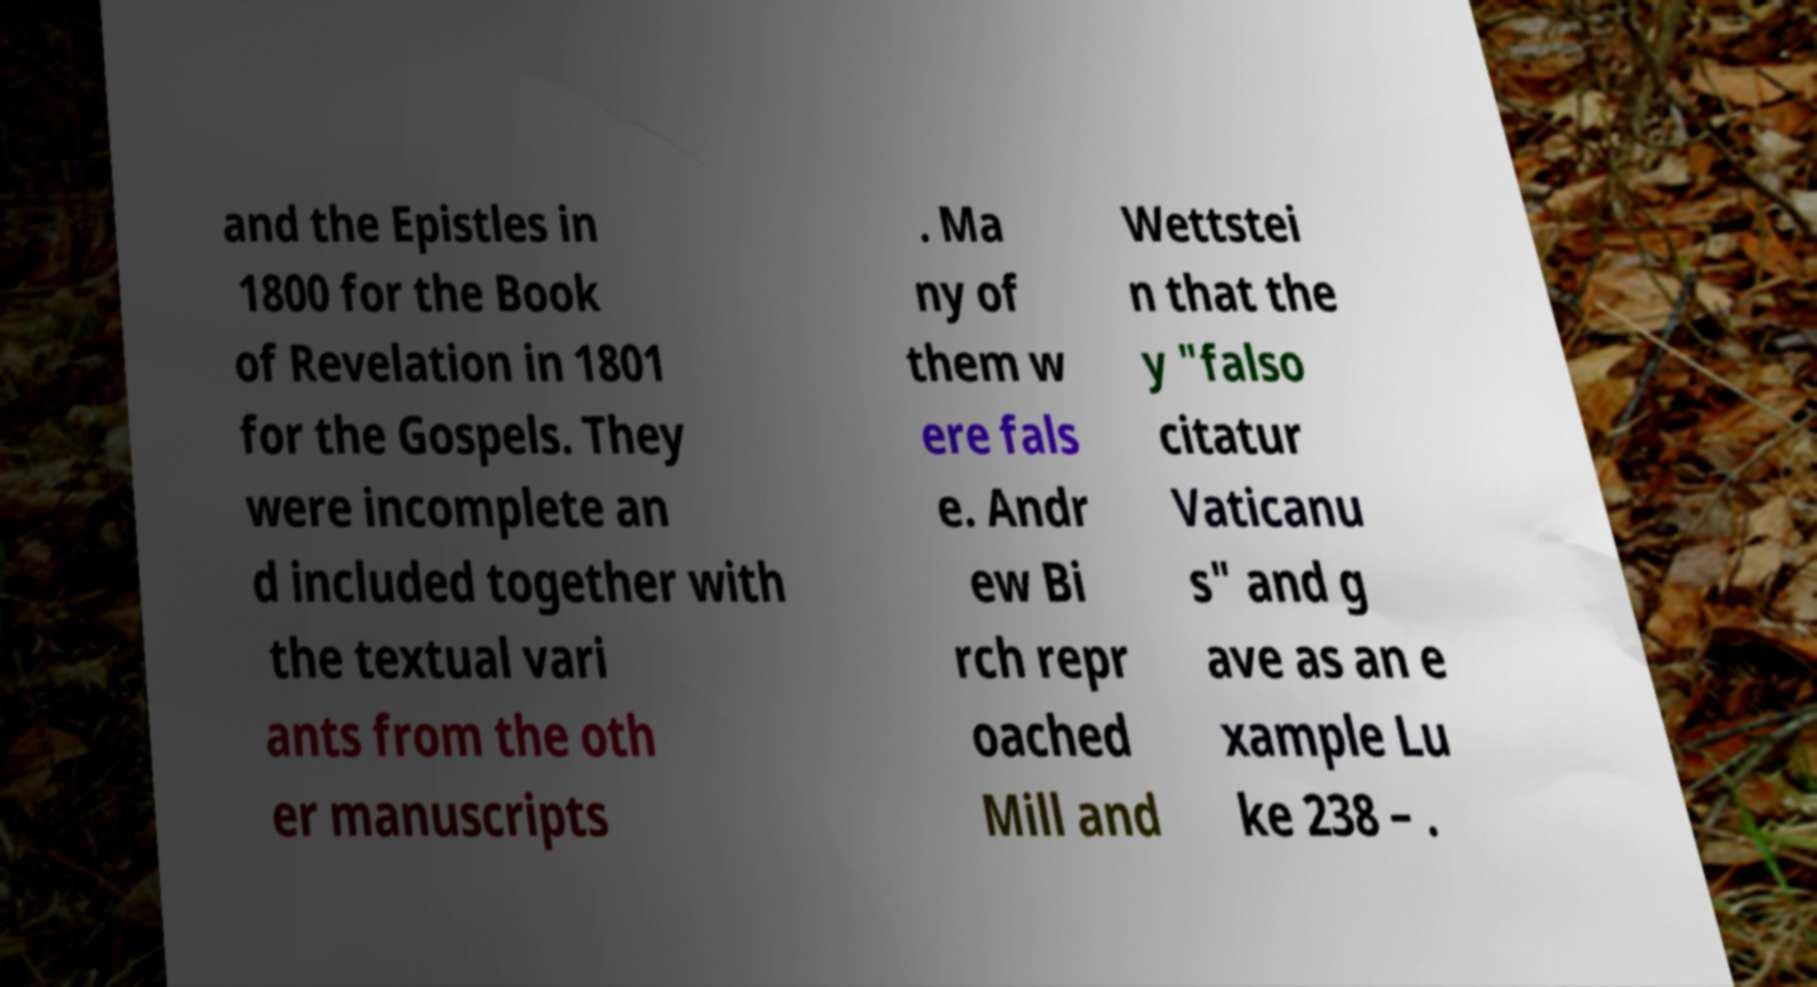There's text embedded in this image that I need extracted. Can you transcribe it verbatim? and the Epistles in 1800 for the Book of Revelation in 1801 for the Gospels. They were incomplete an d included together with the textual vari ants from the oth er manuscripts . Ma ny of them w ere fals e. Andr ew Bi rch repr oached Mill and Wettstei n that the y "falso citatur Vaticanu s" and g ave as an e xample Lu ke 238 – . 